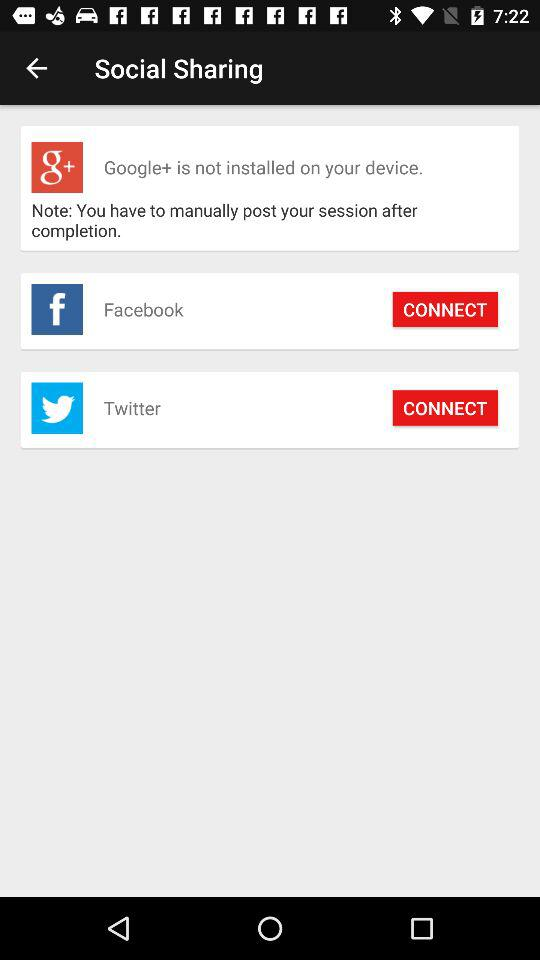What applications can be used to connect? The applications that can be used to connect are "Facebook" and "Twitter". 